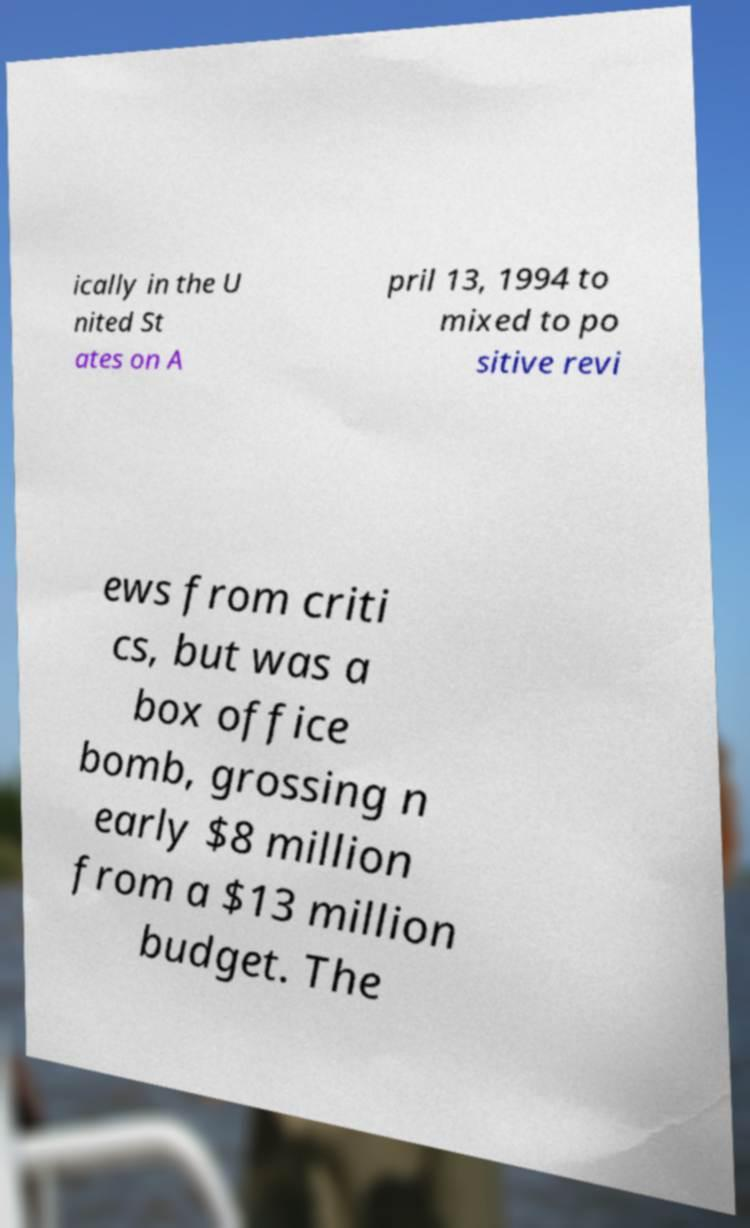For documentation purposes, I need the text within this image transcribed. Could you provide that? ically in the U nited St ates on A pril 13, 1994 to mixed to po sitive revi ews from criti cs, but was a box office bomb, grossing n early $8 million from a $13 million budget. The 